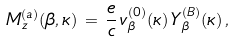<formula> <loc_0><loc_0><loc_500><loc_500>M _ { z } ^ { ( a ) } ( \beta , \kappa ) \, = \, \frac { e } { c } \, v _ { \beta } ^ { ( 0 ) } ( \kappa ) \, Y _ { \beta } ^ { ( B ) } ( \kappa ) \, ,</formula> 